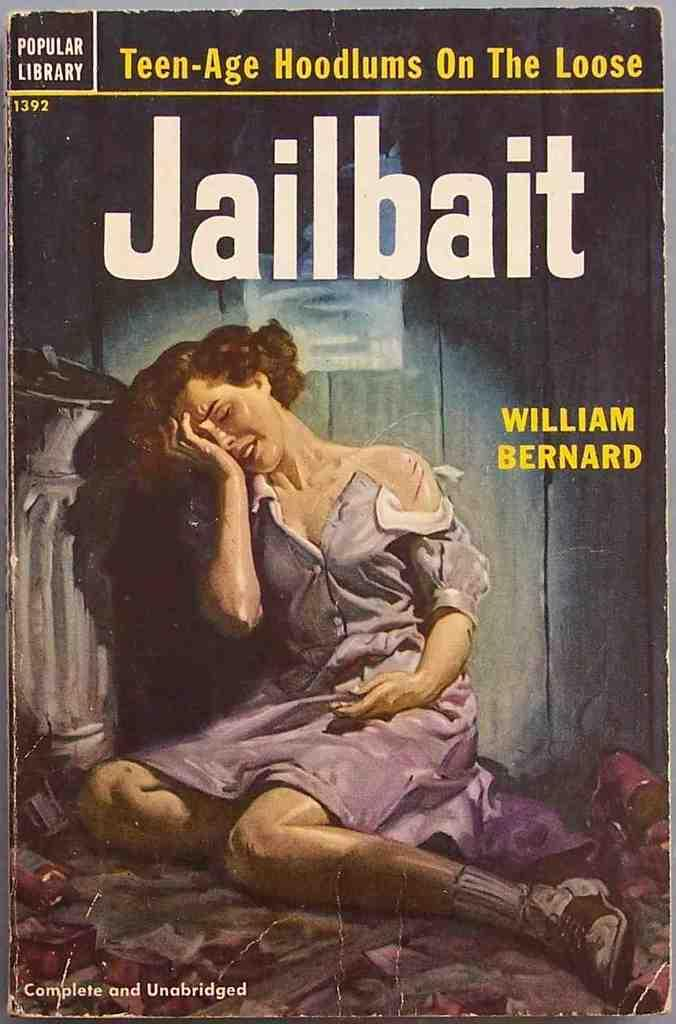<image>
Offer a succinct explanation of the picture presented. A book with a woman crying on the front titled Jailbait. 